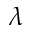Convert formula to latex. <formula><loc_0><loc_0><loc_500><loc_500>\lambda</formula> 